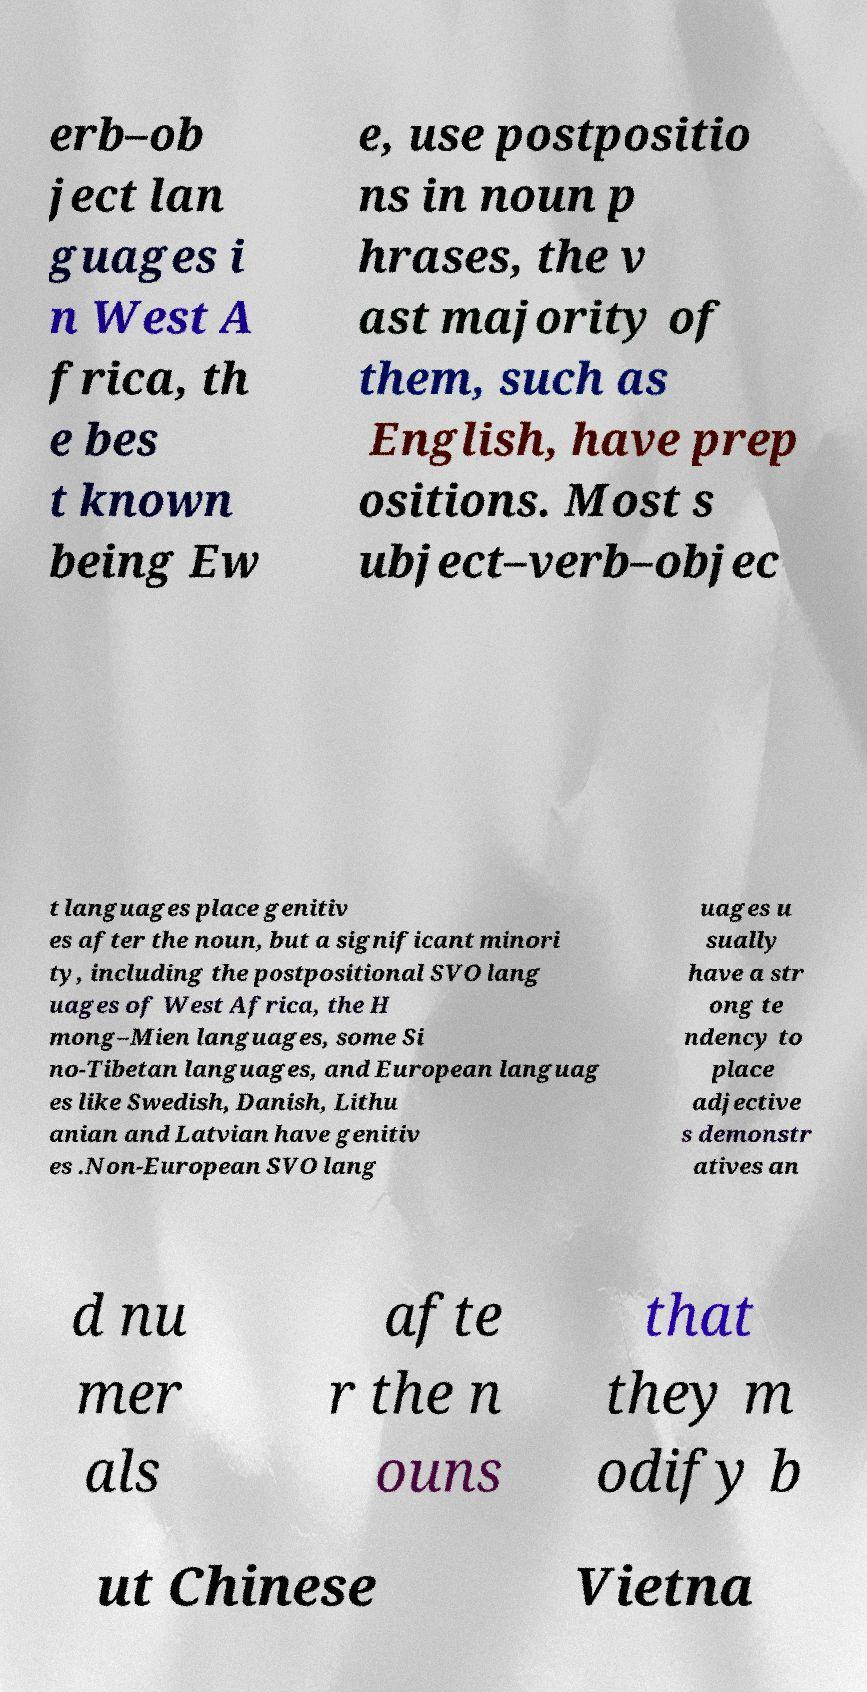Please identify and transcribe the text found in this image. erb–ob ject lan guages i n West A frica, th e bes t known being Ew e, use postpositio ns in noun p hrases, the v ast majority of them, such as English, have prep ositions. Most s ubject–verb–objec t languages place genitiv es after the noun, but a significant minori ty, including the postpositional SVO lang uages of West Africa, the H mong–Mien languages, some Si no-Tibetan languages, and European languag es like Swedish, Danish, Lithu anian and Latvian have genitiv es .Non-European SVO lang uages u sually have a str ong te ndency to place adjective s demonstr atives an d nu mer als afte r the n ouns that they m odify b ut Chinese Vietna 